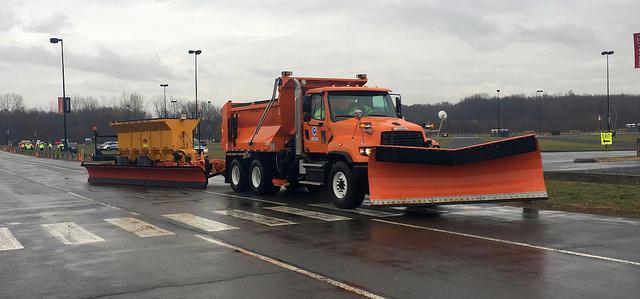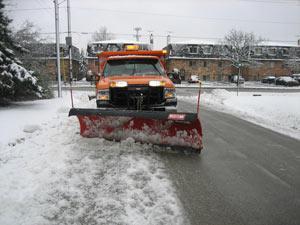The first image is the image on the left, the second image is the image on the right. Analyze the images presented: Is the assertion "One snow plow is parked in a non-snow covered parking lot." valid? Answer yes or no. Yes. The first image is the image on the left, the second image is the image on the right. For the images shown, is this caption "The left and right image contains the same number of orange snow trucks." true? Answer yes or no. Yes. 